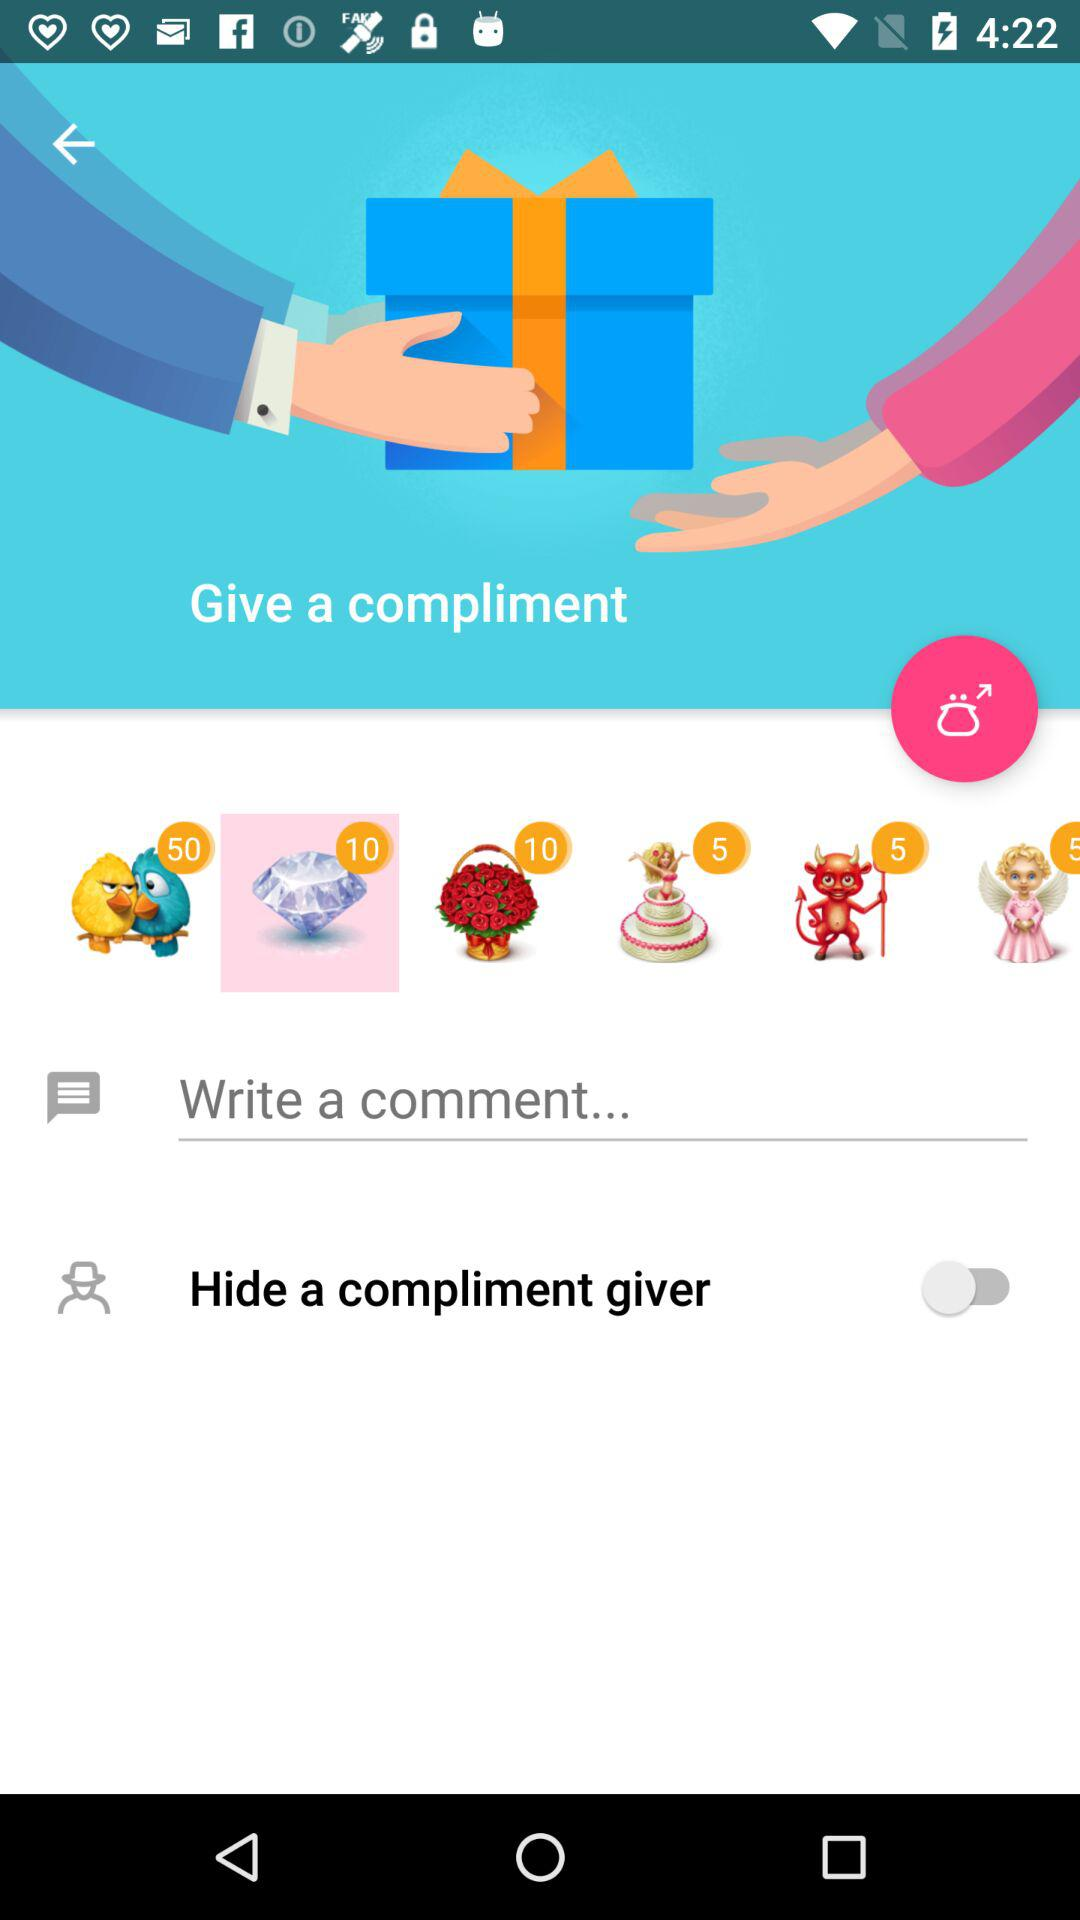What is the status of "Hide a compliment giver"? The status is "off". 